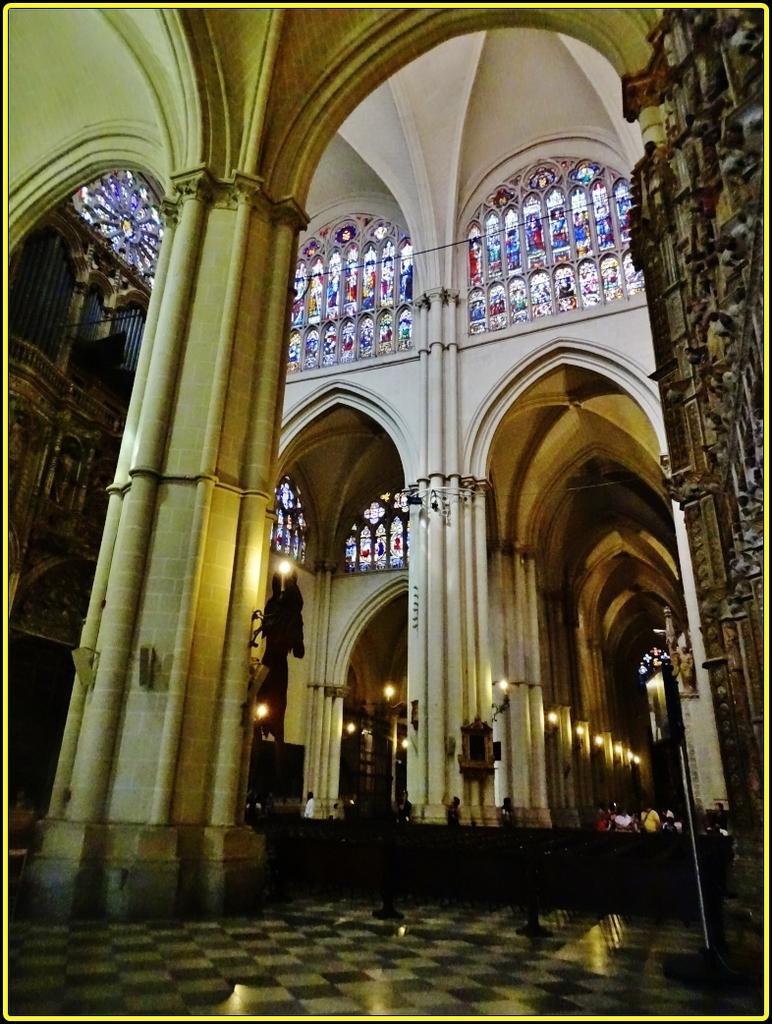In one or two sentences, can you explain what this image depicts? This image is taken from inside, in this image there are few people walking on the floor, there is a pillar and arch of a building, above the arch there is a mirror in which there are paintings on it. At the top of the image there is a dome and on the right side of the image there is a door. 